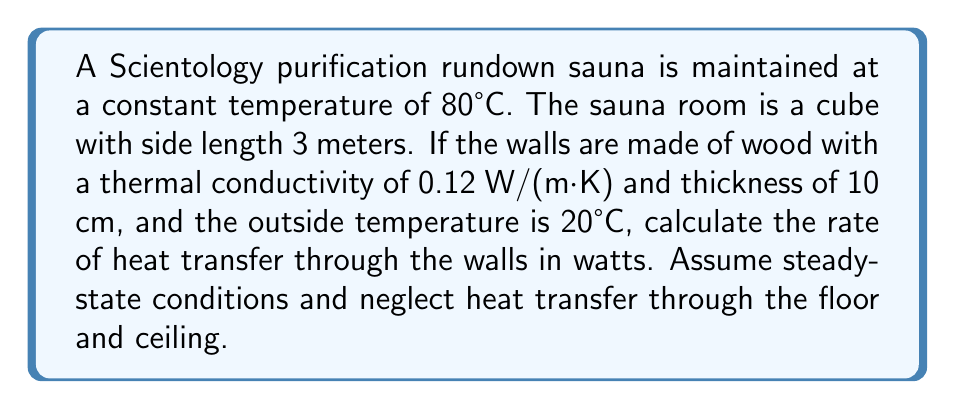Show me your answer to this math problem. To solve this problem, we'll use Fourier's Law of Heat Conduction:

$$Q = -kA\frac{dT}{dx}$$

Where:
$Q$ = rate of heat transfer (W)
$k$ = thermal conductivity (W/(m·K))
$A$ = surface area (m²)
$\frac{dT}{dx}$ = temperature gradient (K/m)

Step 1: Calculate the surface area of the four walls
$$A = 4 * (3 \text{ m} * 3 \text{ m}) = 36 \text{ m}^2$$

Step 2: Calculate the temperature gradient
$$\frac{dT}{dx} = \frac{T_\text{inside} - T_\text{outside}}{\text{thickness}} = \frac{80°C - 20°C}{0.1 \text{ m}} = 600 \text{ K/m}$$

Step 3: Apply Fourier's Law
$$Q = -k * A * \frac{dT}{dx}$$
$$Q = -0.12 \text{ W/(m·K)} * 36 \text{ m}^2 * 600 \text{ K/m}$$
$$Q = -2592 \text{ W}$$

The negative sign indicates that heat is flowing out of the sauna. The magnitude of heat transfer is 2592 W.
Answer: 2592 W 